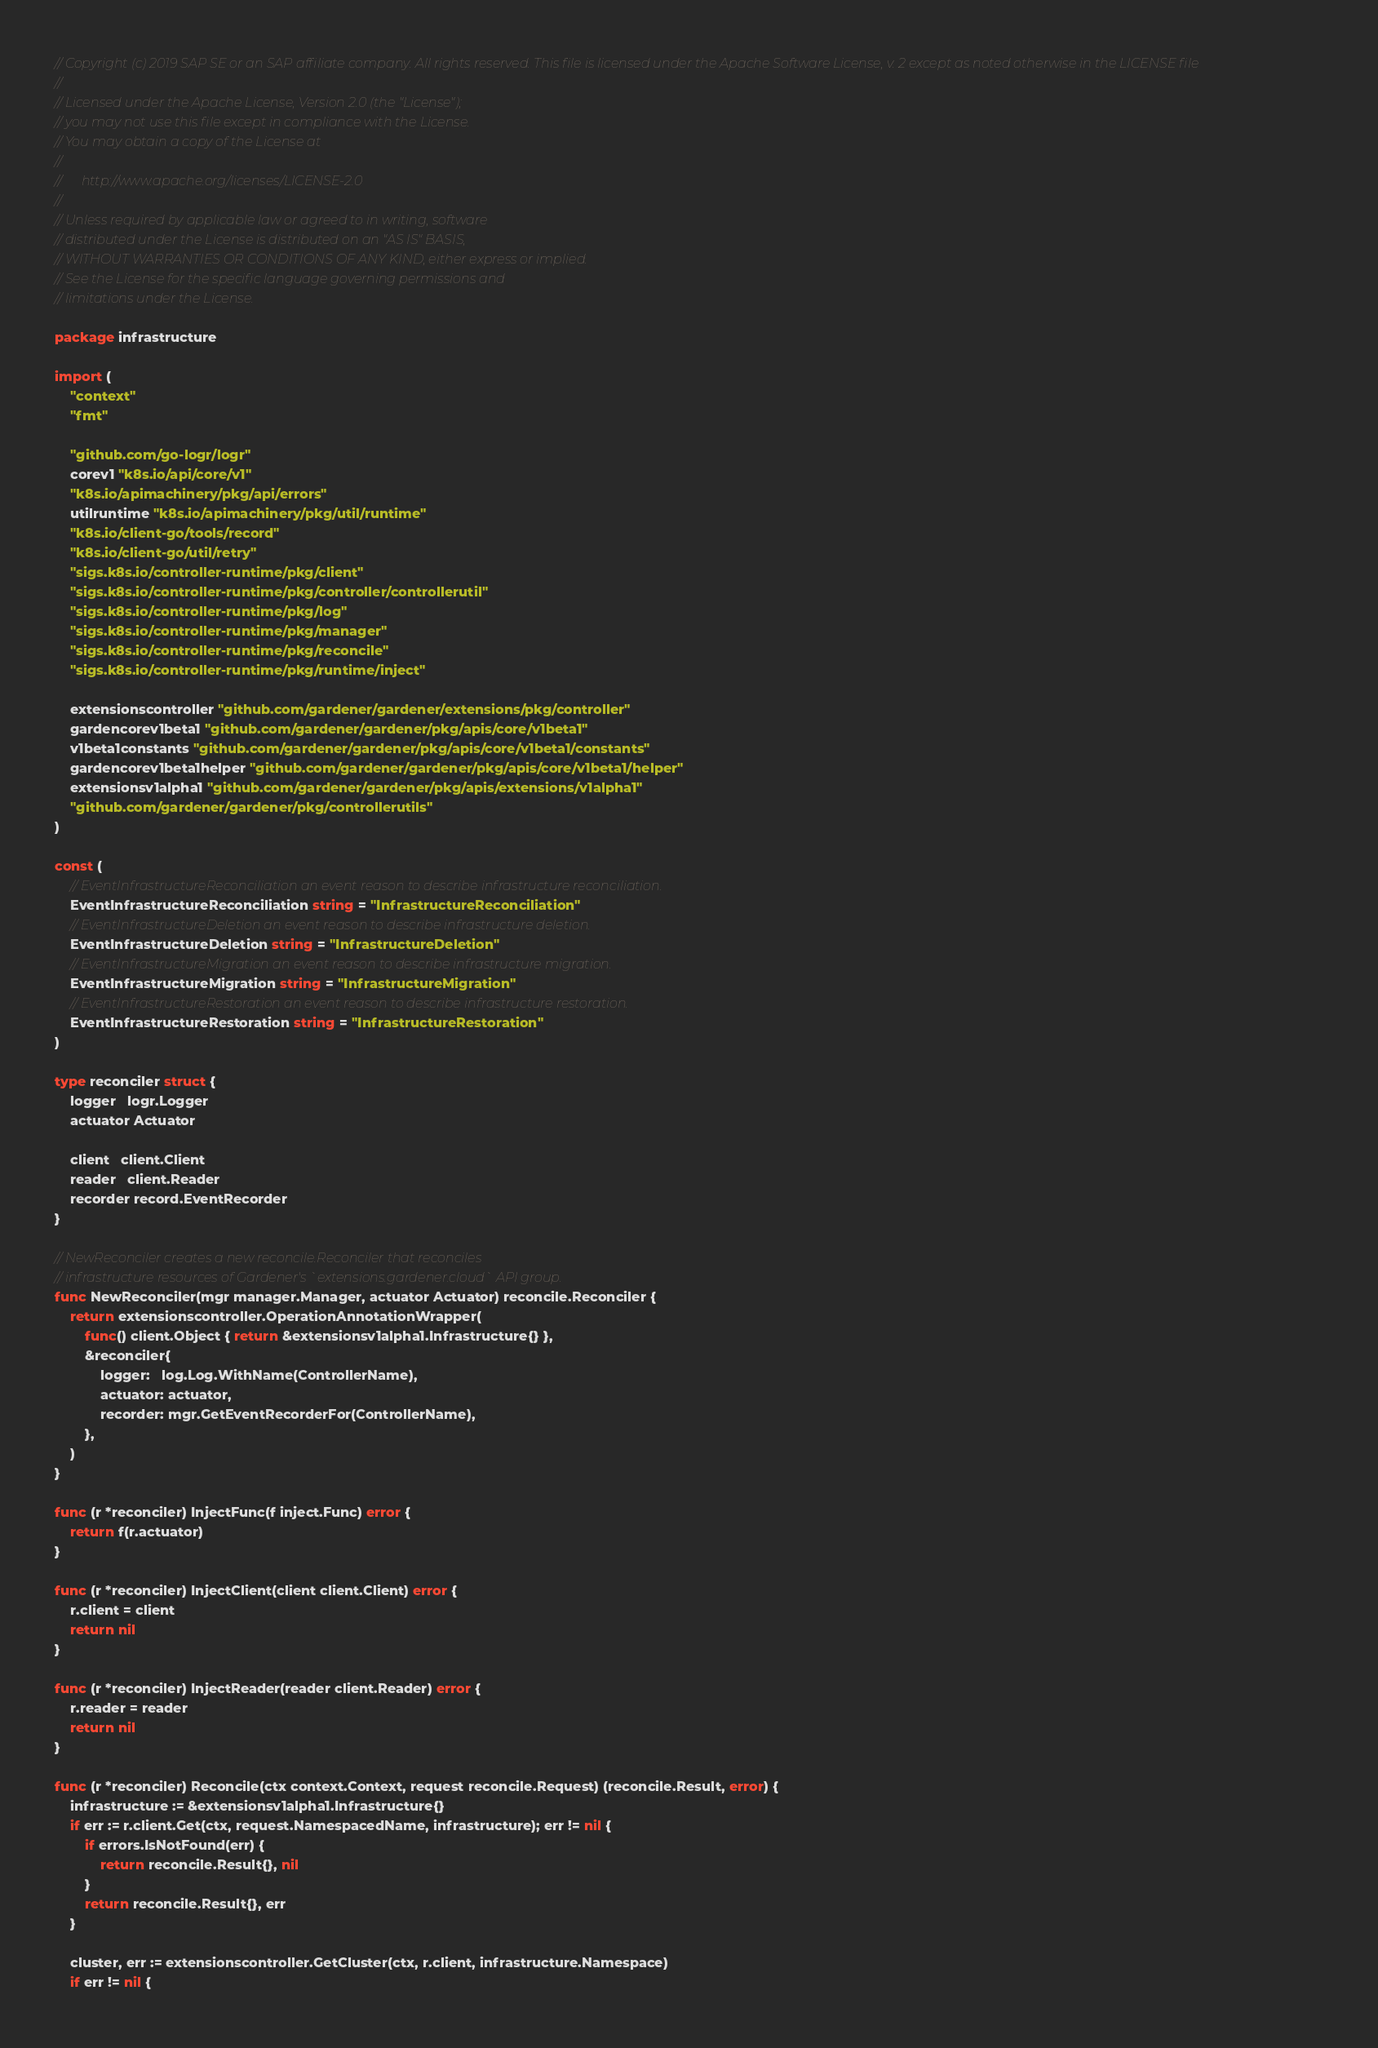Convert code to text. <code><loc_0><loc_0><loc_500><loc_500><_Go_>// Copyright (c) 2019 SAP SE or an SAP affiliate company. All rights reserved. This file is licensed under the Apache Software License, v. 2 except as noted otherwise in the LICENSE file
//
// Licensed under the Apache License, Version 2.0 (the "License");
// you may not use this file except in compliance with the License.
// You may obtain a copy of the License at
//
//      http://www.apache.org/licenses/LICENSE-2.0
//
// Unless required by applicable law or agreed to in writing, software
// distributed under the License is distributed on an "AS IS" BASIS,
// WITHOUT WARRANTIES OR CONDITIONS OF ANY KIND, either express or implied.
// See the License for the specific language governing permissions and
// limitations under the License.

package infrastructure

import (
	"context"
	"fmt"

	"github.com/go-logr/logr"
	corev1 "k8s.io/api/core/v1"
	"k8s.io/apimachinery/pkg/api/errors"
	utilruntime "k8s.io/apimachinery/pkg/util/runtime"
	"k8s.io/client-go/tools/record"
	"k8s.io/client-go/util/retry"
	"sigs.k8s.io/controller-runtime/pkg/client"
	"sigs.k8s.io/controller-runtime/pkg/controller/controllerutil"
	"sigs.k8s.io/controller-runtime/pkg/log"
	"sigs.k8s.io/controller-runtime/pkg/manager"
	"sigs.k8s.io/controller-runtime/pkg/reconcile"
	"sigs.k8s.io/controller-runtime/pkg/runtime/inject"

	extensionscontroller "github.com/gardener/gardener/extensions/pkg/controller"
	gardencorev1beta1 "github.com/gardener/gardener/pkg/apis/core/v1beta1"
	v1beta1constants "github.com/gardener/gardener/pkg/apis/core/v1beta1/constants"
	gardencorev1beta1helper "github.com/gardener/gardener/pkg/apis/core/v1beta1/helper"
	extensionsv1alpha1 "github.com/gardener/gardener/pkg/apis/extensions/v1alpha1"
	"github.com/gardener/gardener/pkg/controllerutils"
)

const (
	// EventInfrastructureReconciliation an event reason to describe infrastructure reconciliation.
	EventInfrastructureReconciliation string = "InfrastructureReconciliation"
	// EventInfrastructureDeletion an event reason to describe infrastructure deletion.
	EventInfrastructureDeletion string = "InfrastructureDeletion"
	// EventInfrastructureMigration an event reason to describe infrastructure migration.
	EventInfrastructureMigration string = "InfrastructureMigration"
	// EventInfrastructureRestoration an event reason to describe infrastructure restoration.
	EventInfrastructureRestoration string = "InfrastructureRestoration"
)

type reconciler struct {
	logger   logr.Logger
	actuator Actuator

	client   client.Client
	reader   client.Reader
	recorder record.EventRecorder
}

// NewReconciler creates a new reconcile.Reconciler that reconciles
// infrastructure resources of Gardener's `extensions.gardener.cloud` API group.
func NewReconciler(mgr manager.Manager, actuator Actuator) reconcile.Reconciler {
	return extensionscontroller.OperationAnnotationWrapper(
		func() client.Object { return &extensionsv1alpha1.Infrastructure{} },
		&reconciler{
			logger:   log.Log.WithName(ControllerName),
			actuator: actuator,
			recorder: mgr.GetEventRecorderFor(ControllerName),
		},
	)
}

func (r *reconciler) InjectFunc(f inject.Func) error {
	return f(r.actuator)
}

func (r *reconciler) InjectClient(client client.Client) error {
	r.client = client
	return nil
}

func (r *reconciler) InjectReader(reader client.Reader) error {
	r.reader = reader
	return nil
}

func (r *reconciler) Reconcile(ctx context.Context, request reconcile.Request) (reconcile.Result, error) {
	infrastructure := &extensionsv1alpha1.Infrastructure{}
	if err := r.client.Get(ctx, request.NamespacedName, infrastructure); err != nil {
		if errors.IsNotFound(err) {
			return reconcile.Result{}, nil
		}
		return reconcile.Result{}, err
	}

	cluster, err := extensionscontroller.GetCluster(ctx, r.client, infrastructure.Namespace)
	if err != nil {</code> 